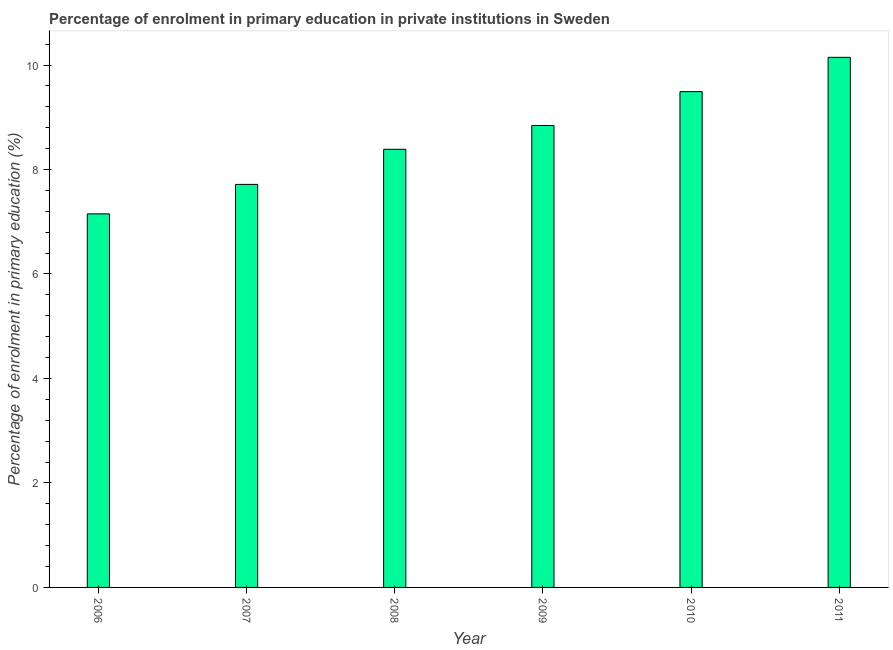What is the title of the graph?
Offer a very short reply. Percentage of enrolment in primary education in private institutions in Sweden. What is the label or title of the Y-axis?
Provide a short and direct response. Percentage of enrolment in primary education (%). What is the enrolment percentage in primary education in 2009?
Make the answer very short. 8.84. Across all years, what is the maximum enrolment percentage in primary education?
Your answer should be very brief. 10.15. Across all years, what is the minimum enrolment percentage in primary education?
Your answer should be very brief. 7.15. What is the sum of the enrolment percentage in primary education?
Provide a succinct answer. 51.73. What is the difference between the enrolment percentage in primary education in 2006 and 2010?
Your answer should be compact. -2.34. What is the average enrolment percentage in primary education per year?
Provide a short and direct response. 8.62. What is the median enrolment percentage in primary education?
Make the answer very short. 8.61. Do a majority of the years between 2009 and 2006 (inclusive) have enrolment percentage in primary education greater than 1.6 %?
Your answer should be very brief. Yes. What is the difference between the highest and the second highest enrolment percentage in primary education?
Your answer should be very brief. 0.66. In how many years, is the enrolment percentage in primary education greater than the average enrolment percentage in primary education taken over all years?
Provide a short and direct response. 3. Are all the bars in the graph horizontal?
Keep it short and to the point. No. How many years are there in the graph?
Ensure brevity in your answer.  6. What is the difference between two consecutive major ticks on the Y-axis?
Make the answer very short. 2. Are the values on the major ticks of Y-axis written in scientific E-notation?
Your answer should be compact. No. What is the Percentage of enrolment in primary education (%) in 2006?
Provide a succinct answer. 7.15. What is the Percentage of enrolment in primary education (%) of 2007?
Your response must be concise. 7.71. What is the Percentage of enrolment in primary education (%) in 2008?
Your answer should be compact. 8.39. What is the Percentage of enrolment in primary education (%) in 2009?
Offer a terse response. 8.84. What is the Percentage of enrolment in primary education (%) of 2010?
Give a very brief answer. 9.49. What is the Percentage of enrolment in primary education (%) in 2011?
Your answer should be very brief. 10.15. What is the difference between the Percentage of enrolment in primary education (%) in 2006 and 2007?
Ensure brevity in your answer.  -0.56. What is the difference between the Percentage of enrolment in primary education (%) in 2006 and 2008?
Give a very brief answer. -1.24. What is the difference between the Percentage of enrolment in primary education (%) in 2006 and 2009?
Your answer should be very brief. -1.69. What is the difference between the Percentage of enrolment in primary education (%) in 2006 and 2010?
Make the answer very short. -2.34. What is the difference between the Percentage of enrolment in primary education (%) in 2006 and 2011?
Provide a short and direct response. -3. What is the difference between the Percentage of enrolment in primary education (%) in 2007 and 2008?
Your response must be concise. -0.67. What is the difference between the Percentage of enrolment in primary education (%) in 2007 and 2009?
Make the answer very short. -1.13. What is the difference between the Percentage of enrolment in primary education (%) in 2007 and 2010?
Your response must be concise. -1.78. What is the difference between the Percentage of enrolment in primary education (%) in 2007 and 2011?
Offer a very short reply. -2.43. What is the difference between the Percentage of enrolment in primary education (%) in 2008 and 2009?
Offer a very short reply. -0.46. What is the difference between the Percentage of enrolment in primary education (%) in 2008 and 2010?
Your answer should be very brief. -1.1. What is the difference between the Percentage of enrolment in primary education (%) in 2008 and 2011?
Give a very brief answer. -1.76. What is the difference between the Percentage of enrolment in primary education (%) in 2009 and 2010?
Your response must be concise. -0.65. What is the difference between the Percentage of enrolment in primary education (%) in 2009 and 2011?
Provide a short and direct response. -1.3. What is the difference between the Percentage of enrolment in primary education (%) in 2010 and 2011?
Your answer should be compact. -0.66. What is the ratio of the Percentage of enrolment in primary education (%) in 2006 to that in 2007?
Provide a short and direct response. 0.93. What is the ratio of the Percentage of enrolment in primary education (%) in 2006 to that in 2008?
Your response must be concise. 0.85. What is the ratio of the Percentage of enrolment in primary education (%) in 2006 to that in 2009?
Provide a succinct answer. 0.81. What is the ratio of the Percentage of enrolment in primary education (%) in 2006 to that in 2010?
Make the answer very short. 0.75. What is the ratio of the Percentage of enrolment in primary education (%) in 2006 to that in 2011?
Offer a terse response. 0.7. What is the ratio of the Percentage of enrolment in primary education (%) in 2007 to that in 2008?
Your response must be concise. 0.92. What is the ratio of the Percentage of enrolment in primary education (%) in 2007 to that in 2009?
Ensure brevity in your answer.  0.87. What is the ratio of the Percentage of enrolment in primary education (%) in 2007 to that in 2010?
Keep it short and to the point. 0.81. What is the ratio of the Percentage of enrolment in primary education (%) in 2007 to that in 2011?
Your answer should be compact. 0.76. What is the ratio of the Percentage of enrolment in primary education (%) in 2008 to that in 2009?
Provide a short and direct response. 0.95. What is the ratio of the Percentage of enrolment in primary education (%) in 2008 to that in 2010?
Offer a terse response. 0.88. What is the ratio of the Percentage of enrolment in primary education (%) in 2008 to that in 2011?
Offer a very short reply. 0.83. What is the ratio of the Percentage of enrolment in primary education (%) in 2009 to that in 2010?
Provide a succinct answer. 0.93. What is the ratio of the Percentage of enrolment in primary education (%) in 2009 to that in 2011?
Make the answer very short. 0.87. What is the ratio of the Percentage of enrolment in primary education (%) in 2010 to that in 2011?
Keep it short and to the point. 0.94. 